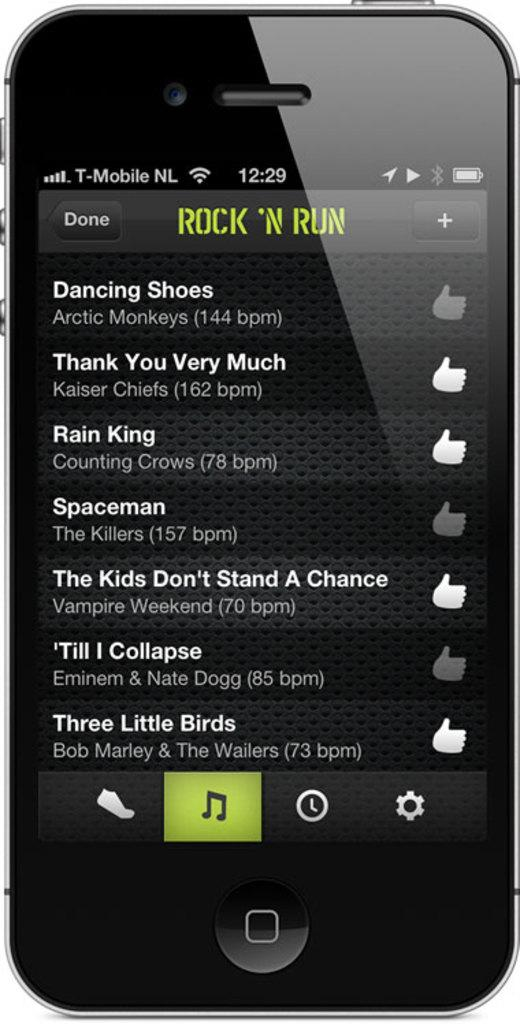<image>
Create a compact narrative representing the image presented. A screen shot of a cell phone with a musical playlist with at least one song by Vampire Weekend. 